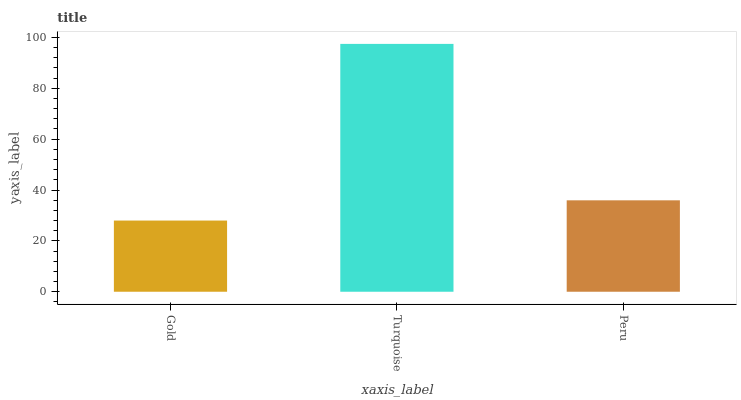Is Peru the minimum?
Answer yes or no. No. Is Peru the maximum?
Answer yes or no. No. Is Turquoise greater than Peru?
Answer yes or no. Yes. Is Peru less than Turquoise?
Answer yes or no. Yes. Is Peru greater than Turquoise?
Answer yes or no. No. Is Turquoise less than Peru?
Answer yes or no. No. Is Peru the high median?
Answer yes or no. Yes. Is Peru the low median?
Answer yes or no. Yes. Is Turquoise the high median?
Answer yes or no. No. Is Turquoise the low median?
Answer yes or no. No. 